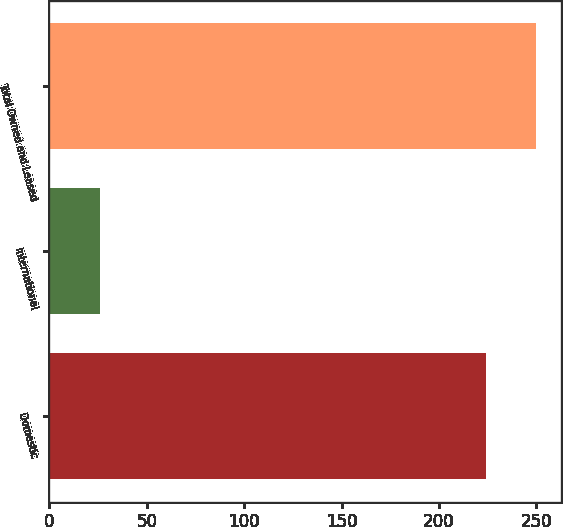<chart> <loc_0><loc_0><loc_500><loc_500><bar_chart><fcel>Domestic<fcel>International<fcel>Total Owned and Leased<nl><fcel>224<fcel>26<fcel>250<nl></chart> 